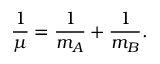<formula> <loc_0><loc_0><loc_500><loc_500>{ \frac { 1 } { \mu } } = { \frac { 1 } { m _ { A } } } + { \frac { 1 } { m _ { B } } } .</formula> 